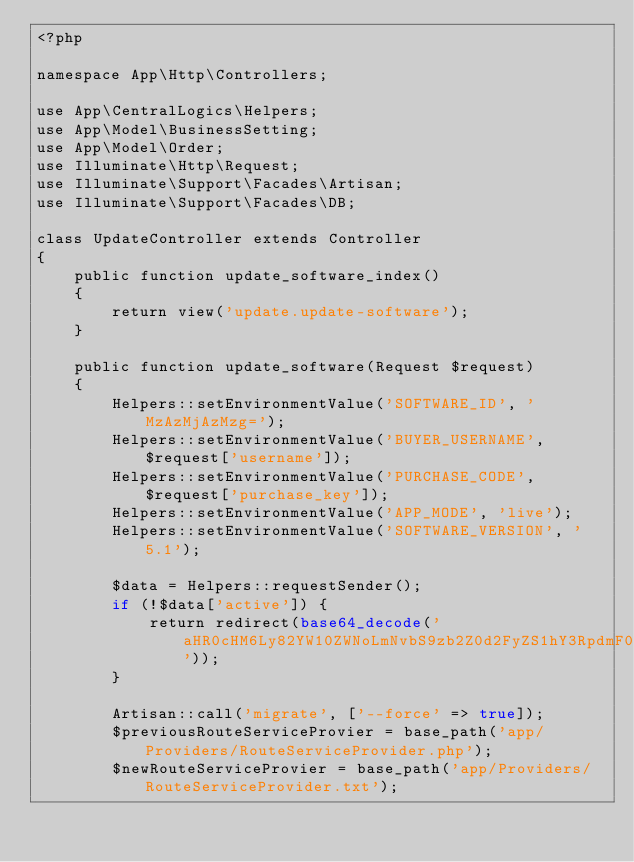Convert code to text. <code><loc_0><loc_0><loc_500><loc_500><_PHP_><?php

namespace App\Http\Controllers;

use App\CentralLogics\Helpers;
use App\Model\BusinessSetting;
use App\Model\Order;
use Illuminate\Http\Request;
use Illuminate\Support\Facades\Artisan;
use Illuminate\Support\Facades\DB;

class UpdateController extends Controller
{
    public function update_software_index()
    {
        return view('update.update-software');
    }

    public function update_software(Request $request)
    {
        Helpers::setEnvironmentValue('SOFTWARE_ID', 'MzAzMjAzMzg=');
        Helpers::setEnvironmentValue('BUYER_USERNAME', $request['username']);
        Helpers::setEnvironmentValue('PURCHASE_CODE', $request['purchase_key']);
        Helpers::setEnvironmentValue('APP_MODE', 'live');
        Helpers::setEnvironmentValue('SOFTWARE_VERSION', '5.1');

        $data = Helpers::requestSender();
        if (!$data['active']) {
            return redirect(base64_decode('aHR0cHM6Ly82YW10ZWNoLmNvbS9zb2Z0d2FyZS1hY3RpdmF0aW9u'));
        }

        Artisan::call('migrate', ['--force' => true]);
        $previousRouteServiceProvier = base_path('app/Providers/RouteServiceProvider.php');
        $newRouteServiceProvier = base_path('app/Providers/RouteServiceProvider.txt');</code> 